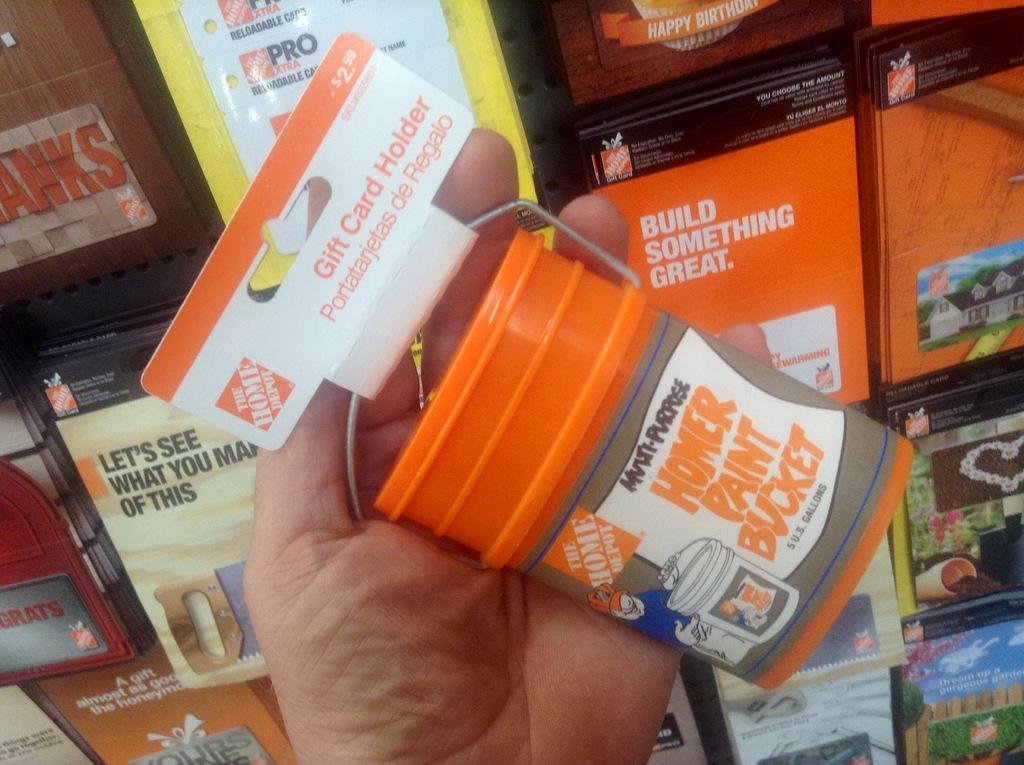<image>
Present a compact description of the photo's key features. A small bucket of paint from the Home Depot that says Multi-Purpose Homer Paint Bucket 